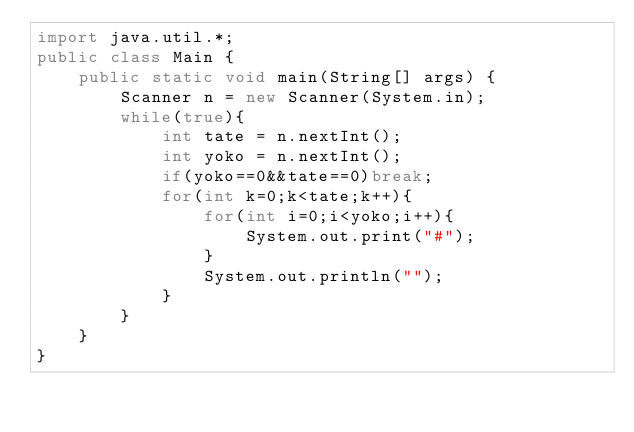<code> <loc_0><loc_0><loc_500><loc_500><_Java_>import java.util.*;
public class Main {
	public static void main(String[] args) {
		Scanner n = new Scanner(System.in);
		while(true){
			int tate = n.nextInt();
			int yoko = n.nextInt();
			if(yoko==0&&tate==0)break;
			for(int k=0;k<tate;k++){
				for(int i=0;i<yoko;i++){
					System.out.print("#");
				}
				System.out.println("");
			}
		}	
	}
}</code> 